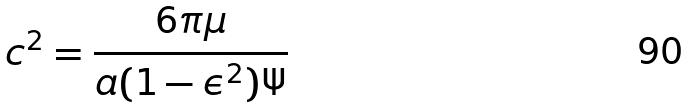<formula> <loc_0><loc_0><loc_500><loc_500>c ^ { 2 } = \frac { 6 \pi \mu } { a ( 1 - \epsilon ^ { 2 } ) \Psi }</formula> 